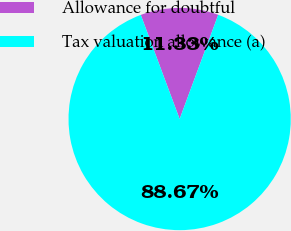Convert chart. <chart><loc_0><loc_0><loc_500><loc_500><pie_chart><fcel>Allowance for doubtful<fcel>Tax valuation allowance (a)<nl><fcel>11.33%<fcel>88.67%<nl></chart> 